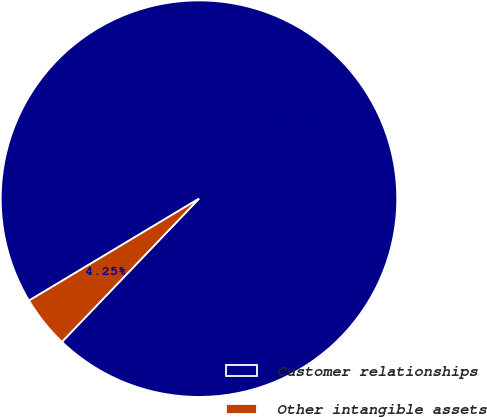<chart> <loc_0><loc_0><loc_500><loc_500><pie_chart><fcel>Customer relationships<fcel>Other intangible assets<nl><fcel>95.75%<fcel>4.25%<nl></chart> 